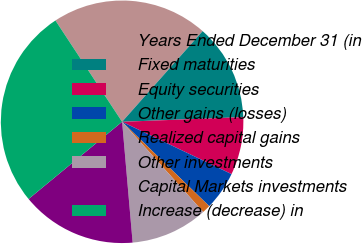Convert chart. <chart><loc_0><loc_0><loc_500><loc_500><pie_chart><fcel>Years Ended December 31 (in<fcel>Fixed maturities<fcel>Equity securities<fcel>Other gains (losses)<fcel>Realized capital gains<fcel>Other investments<fcel>Capital Markets investments<fcel>Increase (decrease) in<nl><fcel>20.82%<fcel>12.83%<fcel>7.71%<fcel>5.15%<fcel>1.1%<fcel>10.27%<fcel>15.4%<fcel>26.72%<nl></chart> 